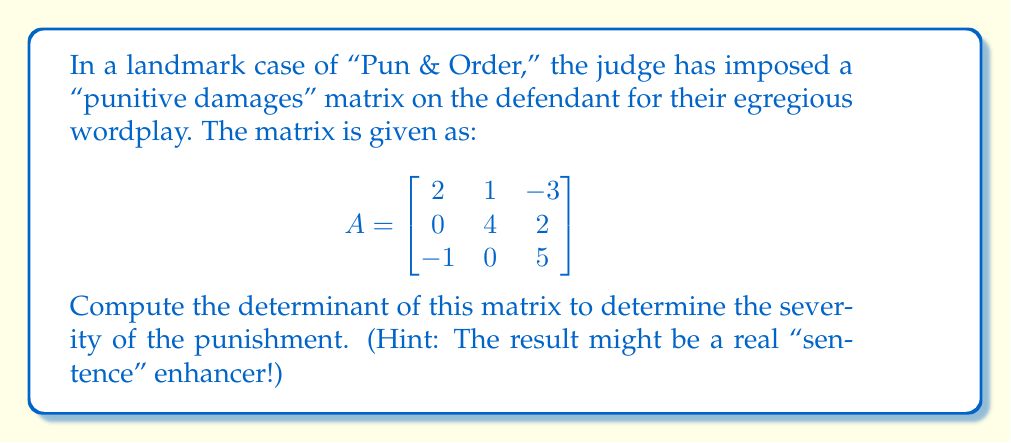Can you solve this math problem? To compute the determinant of the 3x3 matrix A, we'll use the Laplace expansion along the first row. The formula is:

$$det(A) = a_{11}M_{11} - a_{12}M_{12} + a_{13}M_{13}$$

where $M_{ij}$ is the minor of the element $a_{ij}$, obtained by removing the i-th row and j-th column and calculating the determinant of the resulting 2x2 matrix.

Step 1: Calculate $M_{11}$
$$M_{11} = \begin{vmatrix}
4 & 2 \\
0 & 5
\end{vmatrix} = 4(5) - 2(0) = 20$$

Step 2: Calculate $M_{12}$
$$M_{12} = \begin{vmatrix}
0 & 2 \\
-1 & 5
\end{vmatrix} = 0(5) - 2(-1) = 2$$

Step 3: Calculate $M_{13}$
$$M_{13} = \begin{vmatrix}
0 & 4 \\
-1 & 0
\end{vmatrix} = 0(0) - 4(-1) = 4$$

Step 4: Apply the Laplace expansion formula
$$det(A) = 2(20) - 1(2) + (-3)(4)$$
$$det(A) = 40 - 2 - 12$$
$$det(A) = 26$$

Therefore, the determinant of the "punitive damages" matrix is 26.
Answer: The determinant of the "punitive damages" matrix is 26. 